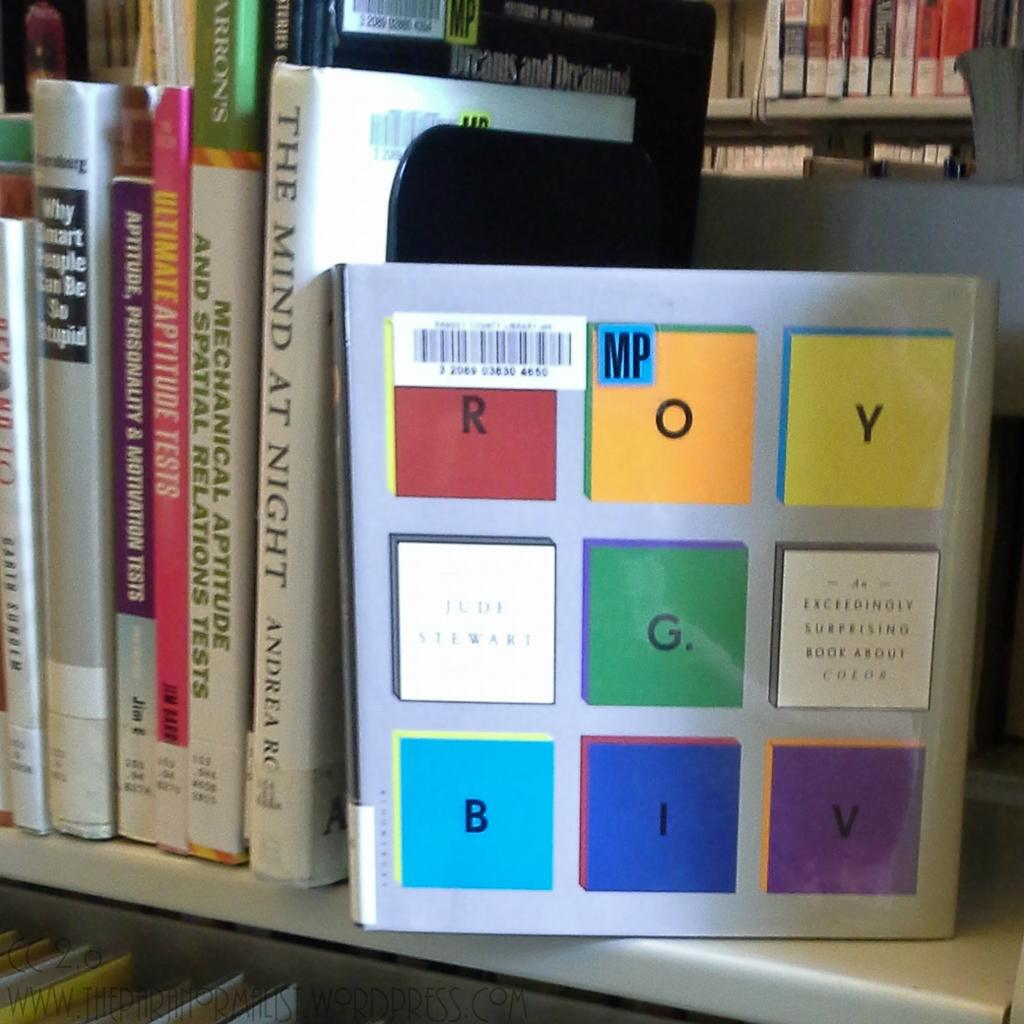<image>
Present a compact description of the photo's key features. a photo that has the name Roy on it 